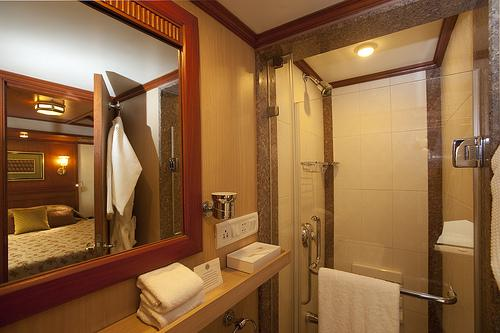Question: how many towels are on the shower door?
Choices:
A. Two.
B. One.
C. Three.
D. Four.
Answer with the letter. Answer: B Question: where was this picture taken?
Choices:
A. Outdoors.
B. Beach.
C. Park.
D. A bathroom.
Answer with the letter. Answer: D Question: what is hanging on the shower door?
Choices:
A. Shower cap.
B. A towel.
C. Clothes.
D. Cloth.
Answer with the letter. Answer: B Question: what is the shower door made of?
Choices:
A. Fiberglass.
B. No door.
C. Glass.
D. Shower curtain.
Answer with the letter. Answer: C 